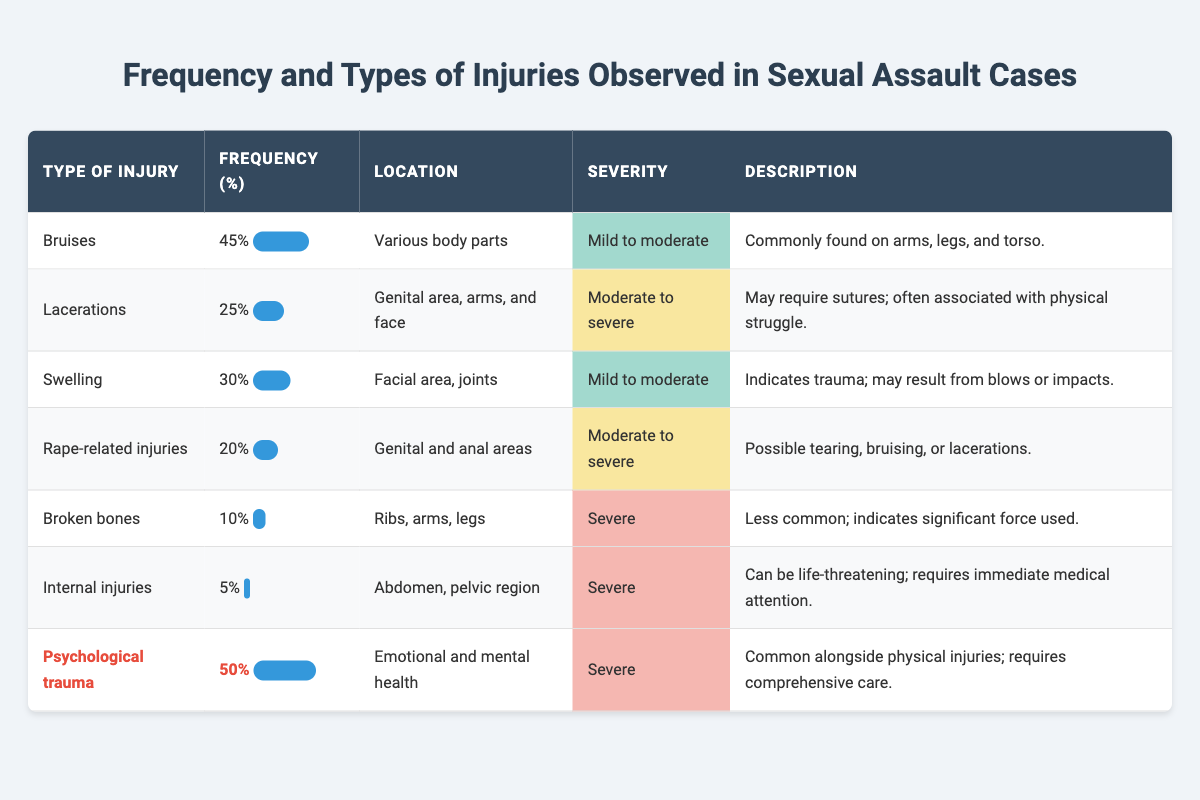What is the most frequently observed injury type? To find the most frequently observed injury, we can look at the 'Frequency' column and identify the highest value. Bruises have the highest frequency at 45%.
Answer: Bruises How many total different injury types are recorded in the table? The table lists seven different types of injuries, which can be counted from the rows under the 'Type of Injury' column.
Answer: 7 What percentage of injuries are related to psychological trauma? According to the table, psychological trauma has a frequency of 50%, which is directly stated in the 'Frequency' column.
Answer: 50% What is the frequency of broken bones compared to lacerations? Broken bones have a frequency of 10%, while lacerations have a frequency of 25%. Comparing these, lacerations are more frequent by 15%.
Answer: Lacerations are more frequent by 15% What is the total frequency of mild to moderate injuries? Mild to moderate injuries include bruises (45%), swelling (30%), and psychological trauma (50%). Summing these: 45% + 30% = 75% for mild to moderate if psychological trauma is excluded.
Answer: 75% Are there any injuries categorized as severe? Yes, both 'Broken bones' and 'Internal injuries' are categorized as severe, as indicated in the 'Severity' column.
Answer: Yes What is the ratio of internal injuries to rape-related injuries? Internal injuries have a frequency of 5%, and rape-related injuries have a frequency of 20%. The ratio is calculated as 5:20, which simplifies to 1:4.
Answer: 1:4 How many injuries require immediate medical attention? Internal injuries are the only type that requires immediate medical attention, as noted in the 'Description' column.
Answer: 1 (Internal injuries) What is the average frequency of moderate to severe injuries? Moderate to severe injuries include lacerations (25%), rape-related injuries (20%), and both types are averaged: (25% + 20%)/2 = 22.5%.
Answer: 22.5% Is there any injury type that occurs in the genital area? Yes, both lacerations and rape-related injuries are noted to occur in the genital area as listed under the 'Location' column.
Answer: Yes 